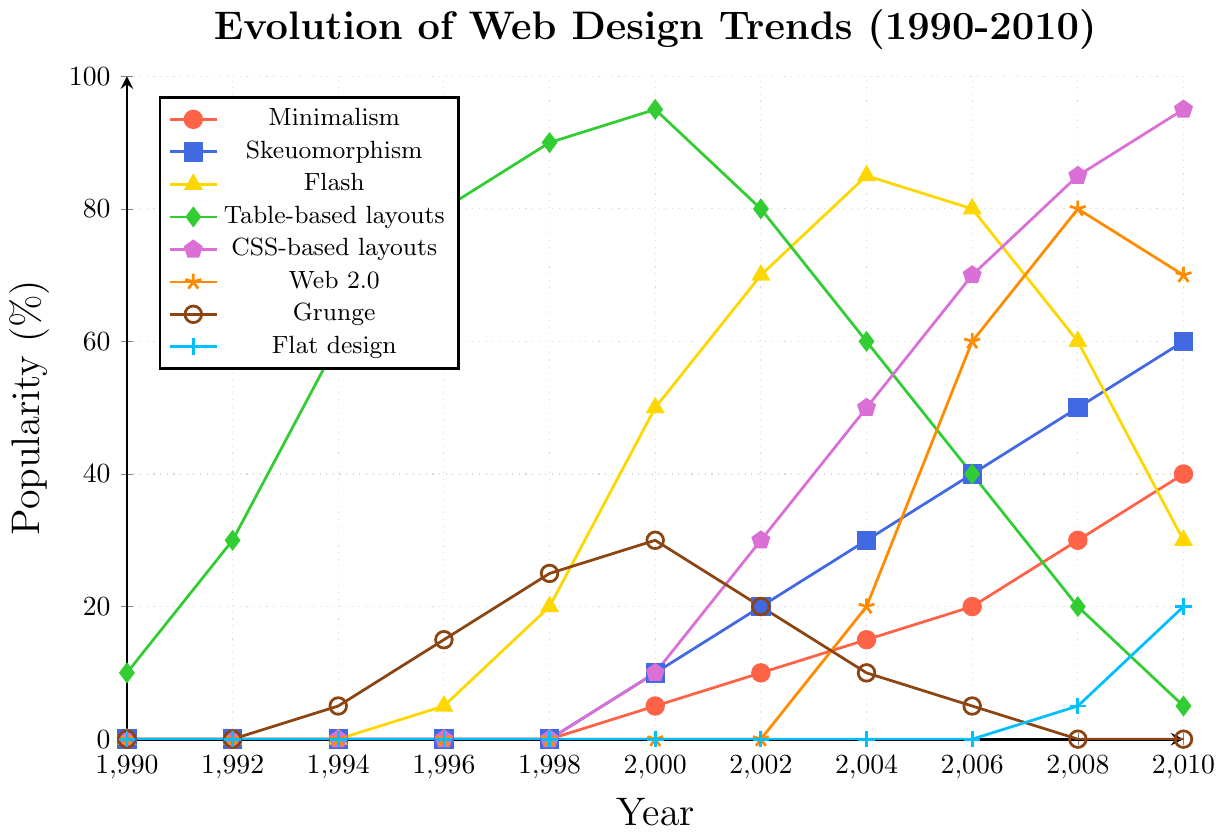What year did the popularity of Flash peak? The popularity of Flash peaks at the highest point in the graph. Observing the plot for the Flash trend (yellow line with triangle markers), it peaks in 2004 at a value of 85%.
Answer: 2004 What two trends were equally popular in 2004? Look at the values in 2004 and find any two trends with the same popularity. Both CSS-based layouts (purple line with pentagon markers) and Flash (yellow line with triangle markers) were at 85% in 2004.
Answer: CSS-based layouts and Flash Which design trend shows a continuous rise from 1990 to 2010? Identify the trend that steadily increases without any dips across the years. Minimalism (red line with circular markers) continuously rises from 1990 to 2010.
Answer: Minimalism Between 2000 and 2010, which trend had the largest decline? Compare all trends between 2000 and 2010 and find the one with the most significant drop in popularity. Flash (yellow line with triangle markers) drops from 50% in 2000 to 30% in 2010.
Answer: Flash In 1998, which design trend reached its peak popularity? Look up the values in 1998 and identify the highest point in that year. Table-based layouts (green line with diamond markers) have their peak in 1998 with a value of 90%.
Answer: Table-based layouts How many trends experienced a decrease in popularity from 2004 to 2006? Observe the changes in popularity values from 2004 to 2006 for all trends. Flash, Table-based layouts, and Grunge experienced a decrease in this period, making it three trends.
Answer: 3 For Grunge, what was the difference in popularity between its peak and its value in 2010? Determine the peak popularity value and the value in 2010 for Grunge and calculate the difference. Grunge peaked at 30% in 2000 but was at 0% in 2010, making the difference 30 - 0 = 30%.
Answer: 30% What is the average popularity of CSS-based layouts from 2000 to 2010? Add the popularity values for CSS-based layouts between 2000 and 2010 and divide by the number of those years. The sum is 10 + 30 + 50 + 70 + 85 + 95 = 340, divided by 6 (number of data points), yielding an average of 56.67%.
Answer: 56.67% Which design trend was more popular than Minimalism but less popular than Skeuomorphism in 2008? Observe the popularity values for 2008. Minimalism is at 30%, Skeuomorphism is at 50%, and Flash is at 60%. Flash is more popular than Minimalism and less popular than Skeuomorphism.
Answer: Flash What year did Web 2.0 first appear on the chart, and what was its popularity at that time? Identify the first year Web 2.0 is plotted on the graph and note the corresponding popularity. Web 2.0 first appears in 2004 with a popularity of 20%.
Answer: 2004, 20% 